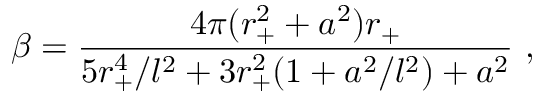Convert formula to latex. <formula><loc_0><loc_0><loc_500><loc_500>\beta = { \frac { 4 \pi ( r _ { + } ^ { 2 } + a ^ { 2 } ) r _ { + } } { 5 r _ { + } ^ { 4 } / l ^ { 2 } + 3 r _ { + } ^ { 2 } ( 1 + a ^ { 2 } / l ^ { 2 } ) + a ^ { 2 } } } \ ,</formula> 